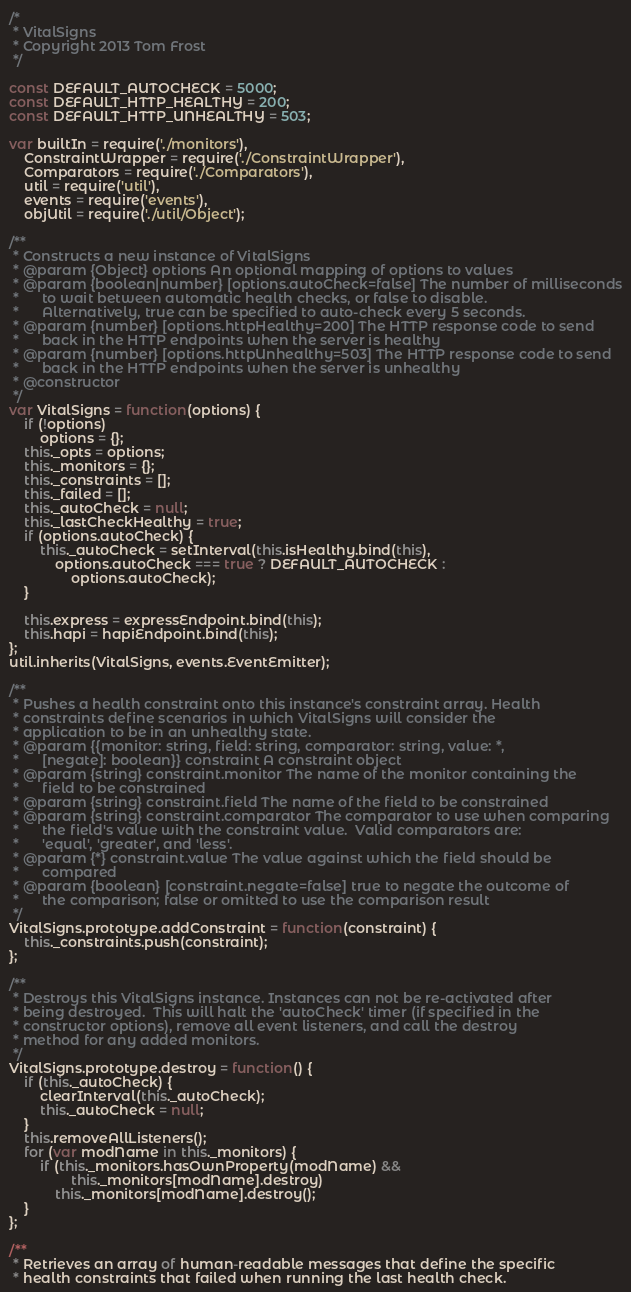<code> <loc_0><loc_0><loc_500><loc_500><_JavaScript_>/*
 * VitalSigns
 * Copyright 2013 Tom Frost
 */

const DEFAULT_AUTOCHECK = 5000;
const DEFAULT_HTTP_HEALTHY = 200;
const DEFAULT_HTTP_UNHEALTHY = 503;

var builtIn = require('./monitors'),
	ConstraintWrapper = require('./ConstraintWrapper'),
	Comparators = require('./Comparators'),
	util = require('util'),
	events = require('events'),
	objUtil = require('./util/Object');

/**
 * Constructs a new instance of VitalSigns
 * @param {Object} options An optional mapping of options to values
 * @param {boolean|number} [options.autoCheck=false] The number of milliseconds
 *      to wait between automatic health checks, or false to disable.
 *      Alternatively, true can be specified to auto-check every 5 seconds.
 * @param {number} [options.httpHealthy=200] The HTTP response code to send
 *      back in the HTTP endpoints when the server is healthy
 * @param {number} [options.httpUnhealthy=503] The HTTP response code to send
 *      back in the HTTP endpoints when the server is unhealthy
 * @constructor
 */
var VitalSigns = function(options) {
	if (!options)
		options = {};
	this._opts = options;
	this._monitors = {};
	this._constraints = [];
	this._failed = [];
	this._autoCheck = null;
	this._lastCheckHealthy = true;
	if (options.autoCheck) {
		this._autoCheck = setInterval(this.isHealthy.bind(this),
			options.autoCheck === true ? DEFAULT_AUTOCHECK :
				options.autoCheck);
	}

	this.express = expressEndpoint.bind(this);
	this.hapi = hapiEndpoint.bind(this);
};
util.inherits(VitalSigns, events.EventEmitter);

/**
 * Pushes a health constraint onto this instance's constraint array. Health
 * constraints define scenarios in which VitalSigns will consider the
 * application to be in an unhealthy state.
 * @param {{monitor: string, field: string, comparator: string, value: *,
 *      [negate]: boolean}} constraint A constraint object
 * @param {string} constraint.monitor The name of the monitor containing the
 *      field to be constrained
 * @param {string} constraint.field The name of the field to be constrained
 * @param {string} constraint.comparator The comparator to use when comparing
 *      the field's value with the constraint value.  Valid comparators are:
 *      'equal', 'greater', and 'less'.
 * @param {*} constraint.value The value against which the field should be
 *      compared
 * @param {boolean} [constraint.negate=false] true to negate the outcome of
 *      the comparison; false or omitted to use the comparison result
 */
VitalSigns.prototype.addConstraint = function(constraint) {
	this._constraints.push(constraint);
};

/**
 * Destroys this VitalSigns instance. Instances can not be re-activated after
 * being destroyed.  This will halt the 'autoCheck' timer (if specified in the
 * constructor options), remove all event listeners, and call the destroy
 * method for any added monitors.
 */
VitalSigns.prototype.destroy = function() {
	if (this._autoCheck) {
		clearInterval(this._autoCheck);
		this._autoCheck = null;
	}
	this.removeAllListeners();
	for (var modName in this._monitors) {
		if (this._monitors.hasOwnProperty(modName) &&
				this._monitors[modName].destroy)
			this._monitors[modName].destroy();
	}
};

/**
 * Retrieves an array of human-readable messages that define the specific
 * health constraints that failed when running the last health check.</code> 